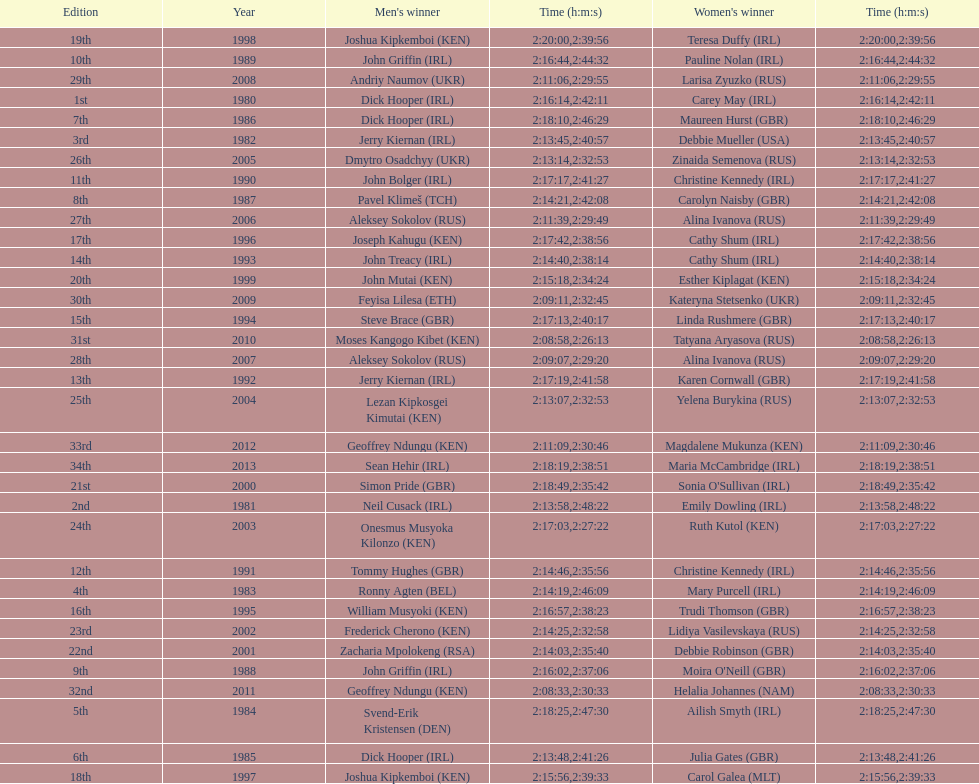How many women's winners are from kenya? 3. 